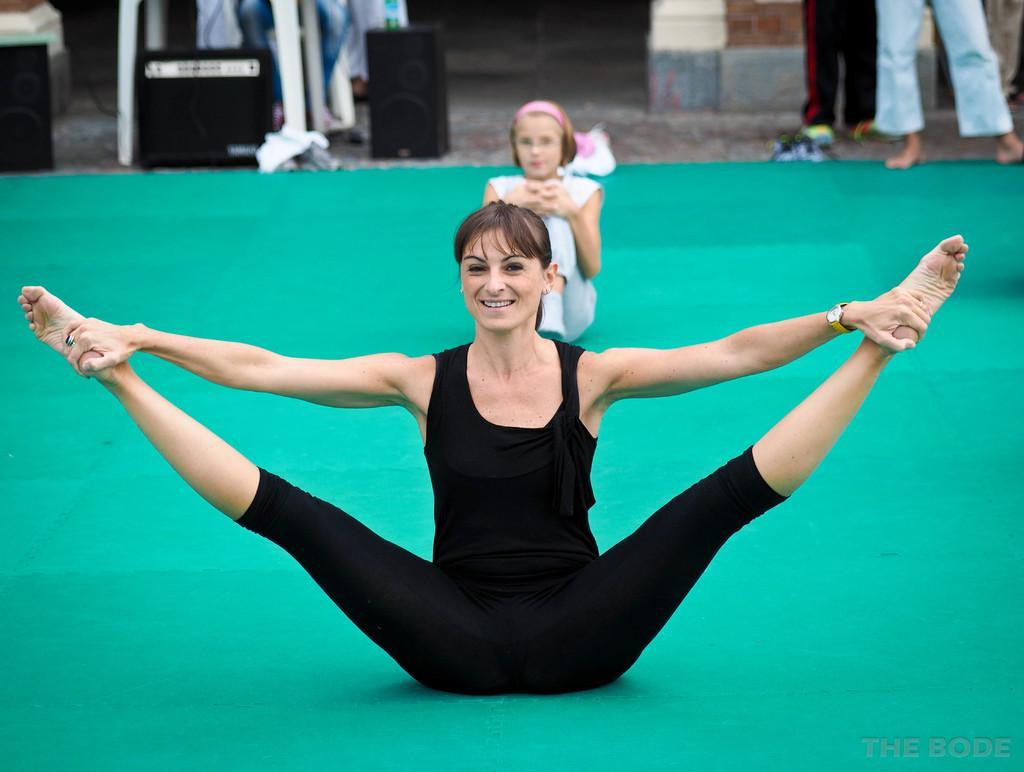In one or two sentences, can you explain what this image depicts? In the foreground we can see a woman doing aerobics on a green mat. In the center there is a girl sitting. On the top there are people, stand, floor and some other objects. 